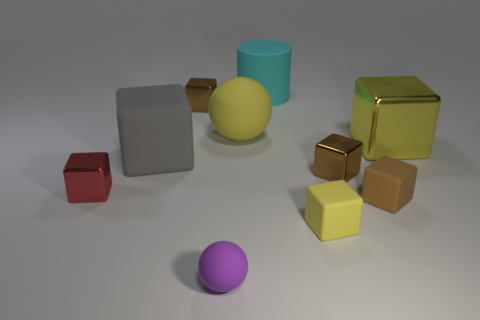Is the brown object on the left side of the large rubber sphere made of the same material as the big yellow block?
Your answer should be very brief. Yes. What is the shape of the big gray object?
Provide a short and direct response. Cube. How many red objects are small cubes or cylinders?
Offer a terse response. 1. How many other things are the same material as the purple thing?
Make the answer very short. 5. There is a big object that is right of the large rubber cylinder; is it the same shape as the big gray object?
Your response must be concise. Yes. Are there any small red objects?
Make the answer very short. Yes. Is there anything else that has the same shape as the tiny red object?
Your answer should be very brief. Yes. Is the number of small yellow matte blocks that are in front of the tiny purple rubber object greater than the number of large gray shiny blocks?
Provide a succinct answer. No. There is a large cyan object; are there any small brown blocks on the left side of it?
Offer a terse response. Yes. Does the purple thing have the same size as the brown rubber cube?
Provide a succinct answer. Yes. 